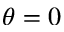<formula> <loc_0><loc_0><loc_500><loc_500>\theta = 0</formula> 